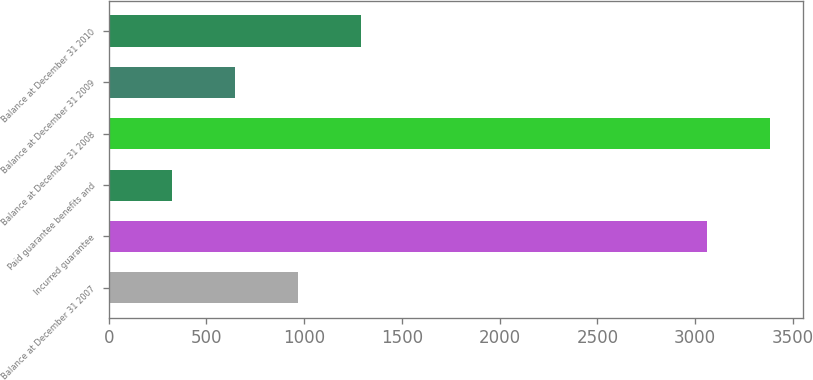<chart> <loc_0><loc_0><loc_500><loc_500><bar_chart><fcel>Balance at December 31 2007<fcel>Incurred guarantee<fcel>Paid guarantee benefits and<fcel>Balance at December 31 2008<fcel>Balance at December 31 2009<fcel>Balance at December 31 2010<nl><fcel>970.2<fcel>3061<fcel>324.84<fcel>3383.68<fcel>647.52<fcel>1292.88<nl></chart> 